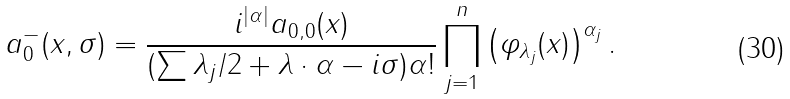Convert formula to latex. <formula><loc_0><loc_0><loc_500><loc_500>a ^ { - } _ { 0 } ( x , \sigma ) = \frac { i ^ { | \alpha | } a _ { 0 , 0 } ( x ) } { ( \sum \lambda _ { j } / 2 + \lambda \cdot \alpha - i \sigma ) \alpha ! } \prod _ { j = 1 } ^ { n } \left ( \varphi _ { \lambda _ { j } } ( x ) \right ) ^ { \alpha _ { j } } .</formula> 